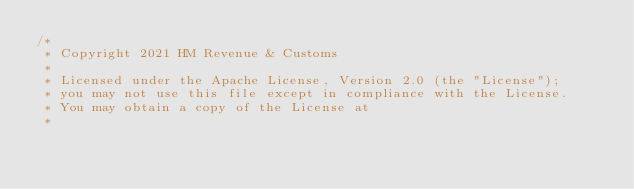Convert code to text. <code><loc_0><loc_0><loc_500><loc_500><_Scala_>/*
 * Copyright 2021 HM Revenue & Customs
 *
 * Licensed under the Apache License, Version 2.0 (the "License");
 * you may not use this file except in compliance with the License.
 * You may obtain a copy of the License at
 *</code> 